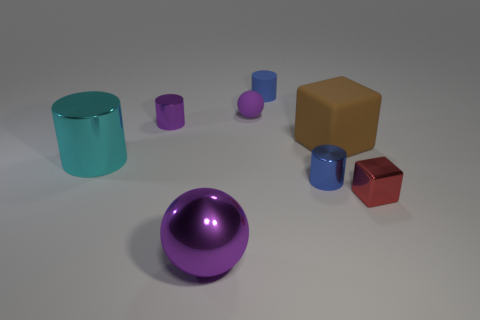What shape is the purple matte thing that is the same size as the blue rubber thing?
Your answer should be very brief. Sphere. There is a small metallic object that is the same color as the small sphere; what is its shape?
Provide a short and direct response. Cylinder. Are there an equal number of red metal things on the right side of the tiny purple cylinder and big yellow spheres?
Offer a very short reply. No. The purple ball behind the metal cube that is in front of the sphere behind the big ball is made of what material?
Provide a short and direct response. Rubber. What is the shape of the large cyan object that is the same material as the red object?
Your answer should be very brief. Cylinder. Is there anything else that is the same color as the matte block?
Offer a very short reply. No. What number of tiny balls are to the left of the small metal thing in front of the metal cylinder to the right of the tiny purple metal thing?
Ensure brevity in your answer.  1. How many red objects are large shiny cylinders or rubber cylinders?
Provide a short and direct response. 0. Do the shiny ball and the blue object that is in front of the cyan cylinder have the same size?
Provide a short and direct response. No. There is a large brown object that is the same shape as the tiny red metallic thing; what is it made of?
Your answer should be very brief. Rubber. 